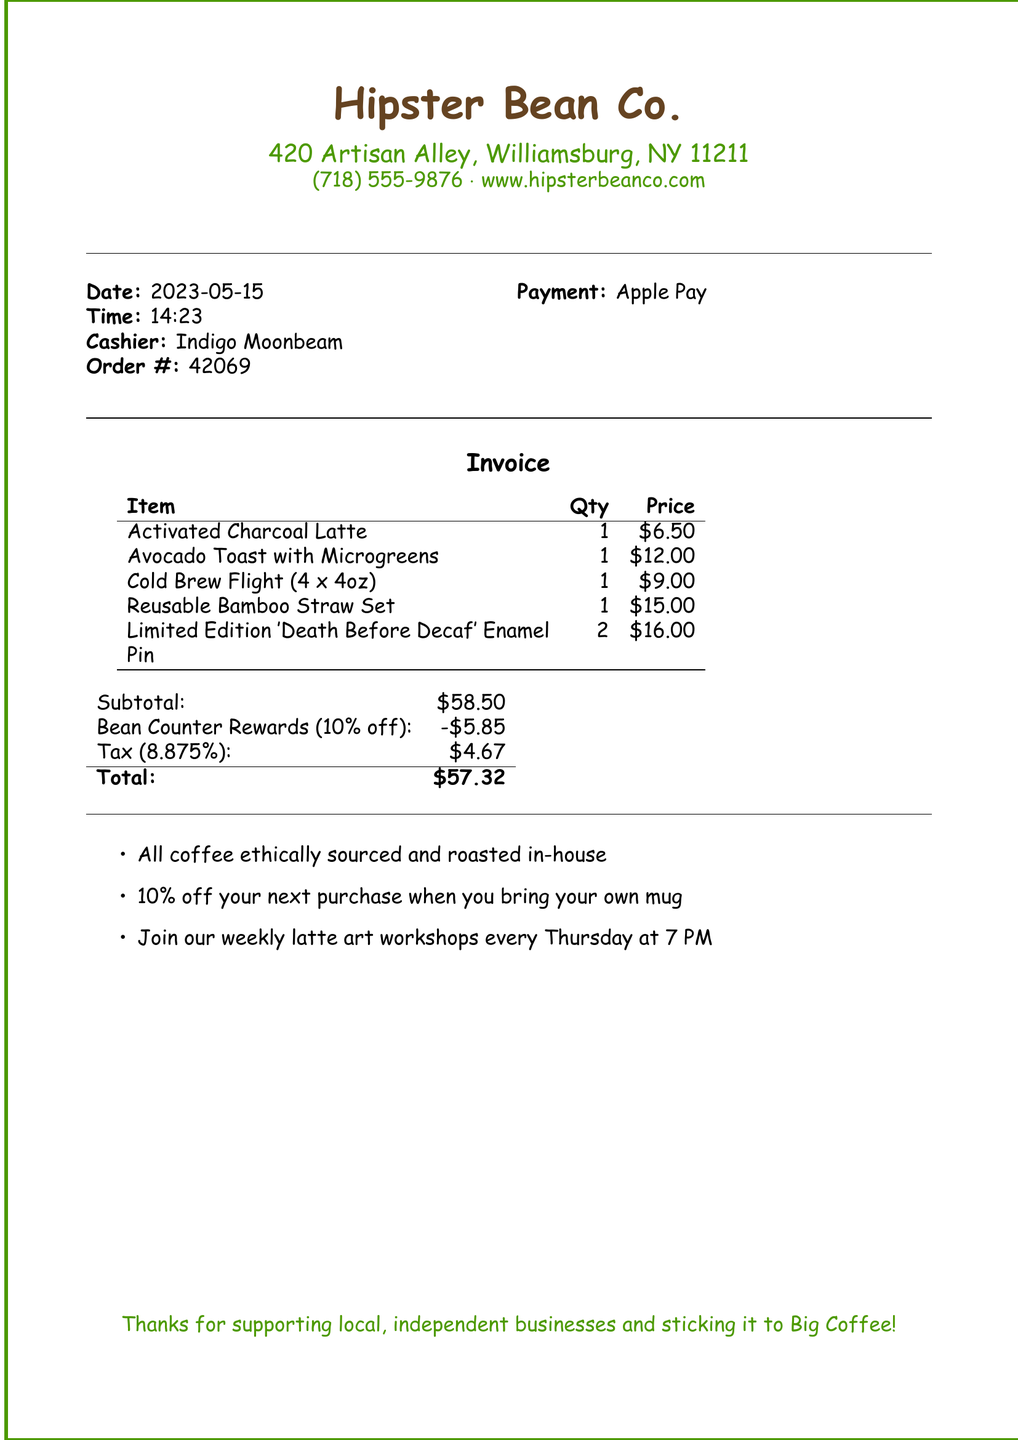what is the business name? The business name is prominently displayed at the top of the document.
Answer: Hipster Bean Co what is the date of the transaction? The date is noted clearly in the document under the date section.
Answer: 2023-05-15 how much was the Activated Charcoal Latte? The price for this specific item is listed in the invoice table.
Answer: $6.50 what was the total amount after the discount? The total amount reflects the subtotal minus the loyalty program discount and includes tax.
Answer: $57.32 what is the name of the loyalty program? The loyalty program is mentioned in the section detailing discounts on the invoice.
Answer: Bean Counter Rewards how many Limited Edition 'Death Before Decaf' Enamel Pins were purchased? The quantity of this specific item is provided in the invoice item list.
Answer: 2 how much was saved through the loyalty program discount? The discount amount appears in the invoice under the loyalty program section.
Answer: $5.85 who was the cashier for this transaction? The cashier's name is listed in the document under cashier details.
Answer: Indigo Moonbeam what type of payment was used? The payment method is specified near the order details.
Answer: Apple Pay 